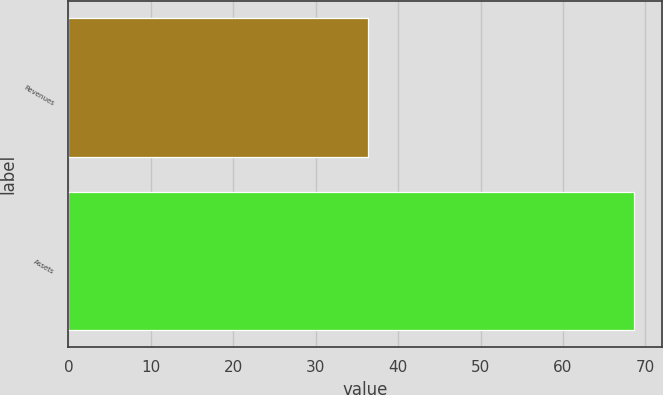Convert chart. <chart><loc_0><loc_0><loc_500><loc_500><bar_chart><fcel>Revenues<fcel>Assets<nl><fcel>36.3<fcel>68.6<nl></chart> 